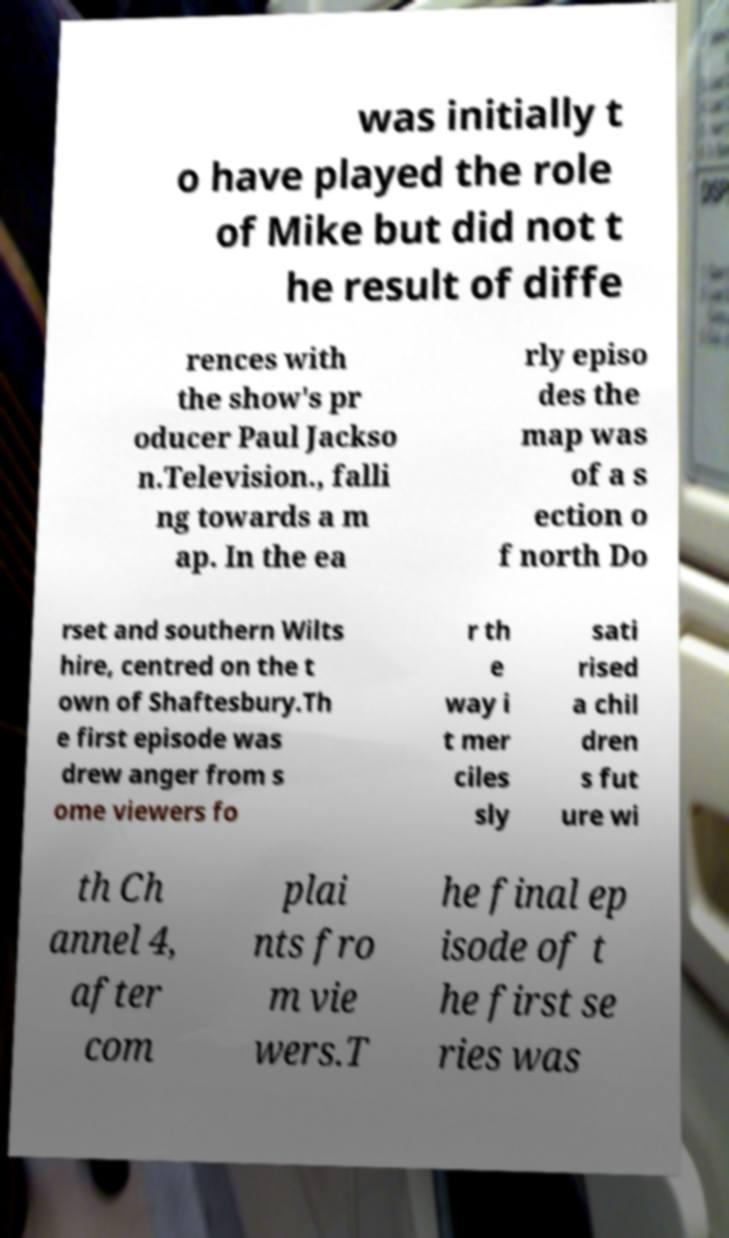Please read and relay the text visible in this image. What does it say? was initially t o have played the role of Mike but did not t he result of diffe rences with the show's pr oducer Paul Jackso n.Television., falli ng towards a m ap. In the ea rly episo des the map was of a s ection o f north Do rset and southern Wilts hire, centred on the t own of Shaftesbury.Th e first episode was drew anger from s ome viewers fo r th e way i t mer ciles sly sati rised a chil dren s fut ure wi th Ch annel 4, after com plai nts fro m vie wers.T he final ep isode of t he first se ries was 